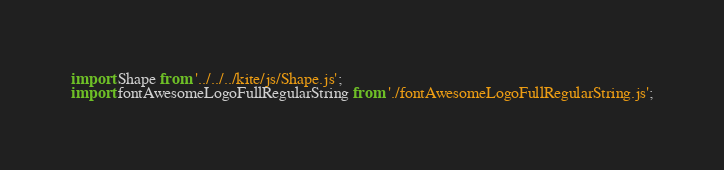<code> <loc_0><loc_0><loc_500><loc_500><_JavaScript_>import Shape from '../../../kite/js/Shape.js';
import fontAwesomeLogoFullRegularString from './fontAwesomeLogoFullRegularString.js';
</code> 